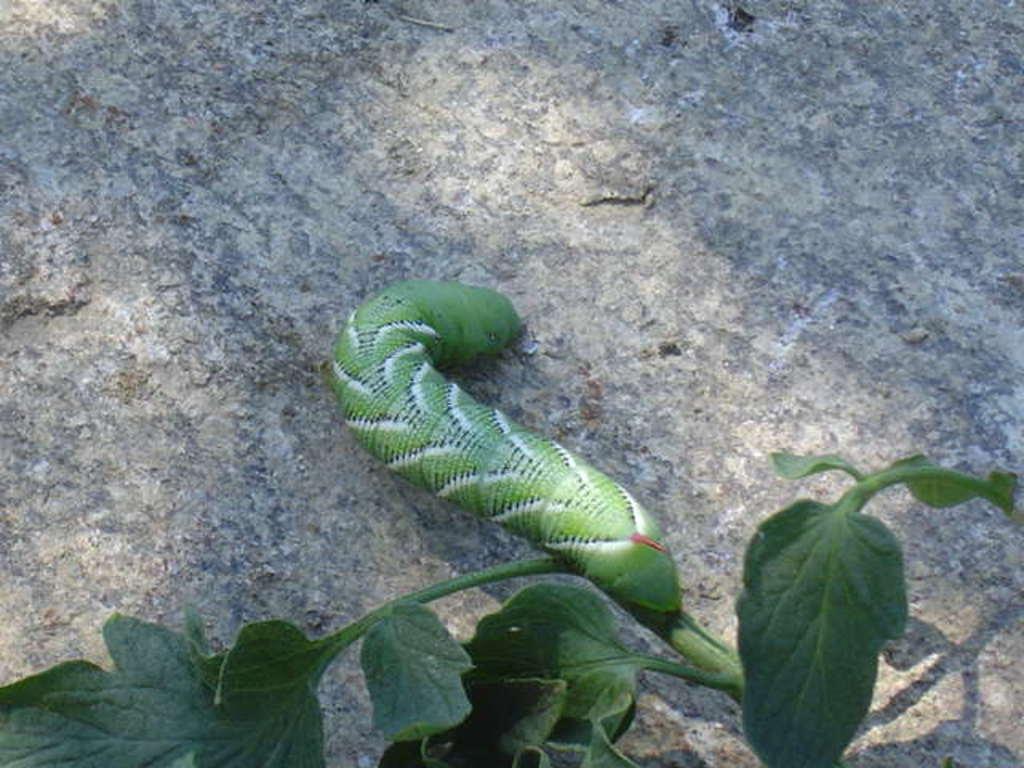In one or two sentences, can you explain what this image depicts? On this stone there is a worm. Bottom of the image there are green leaves. 